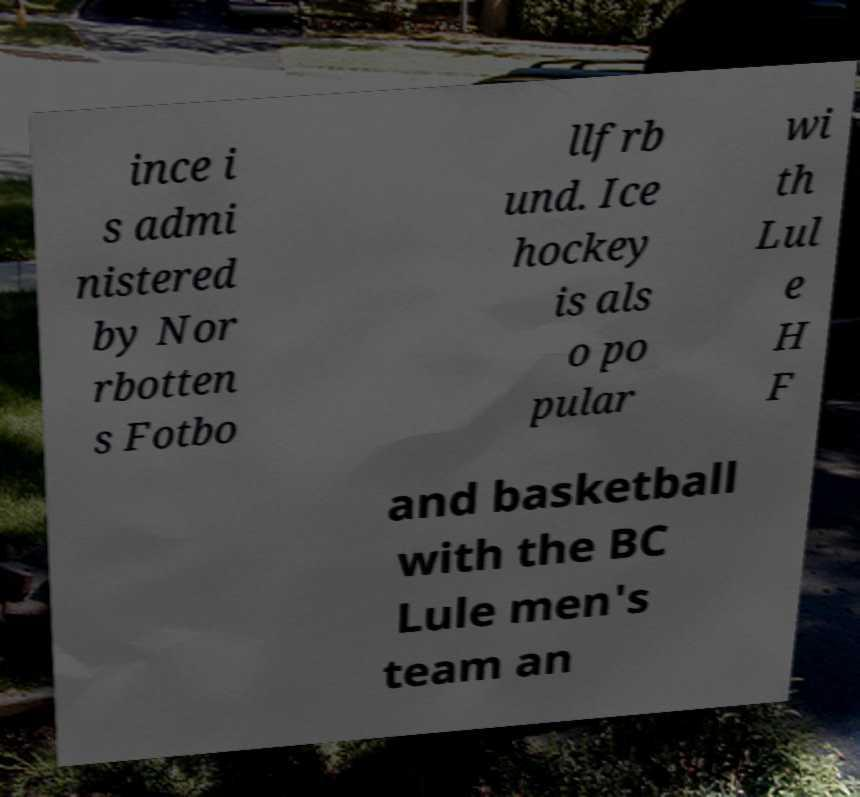For documentation purposes, I need the text within this image transcribed. Could you provide that? ince i s admi nistered by Nor rbotten s Fotbo llfrb und. Ice hockey is als o po pular wi th Lul e H F and basketball with the BC Lule men's team an 